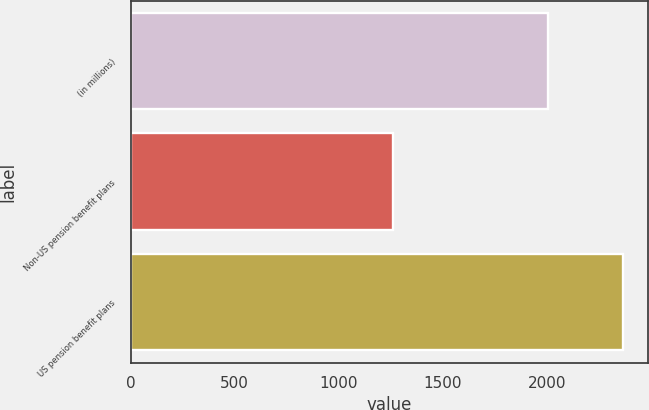Convert chart to OTSL. <chart><loc_0><loc_0><loc_500><loc_500><bar_chart><fcel>(in millions)<fcel>Non-US pension benefit plans<fcel>US pension benefit plans<nl><fcel>2004<fcel>1260<fcel>2367<nl></chart> 